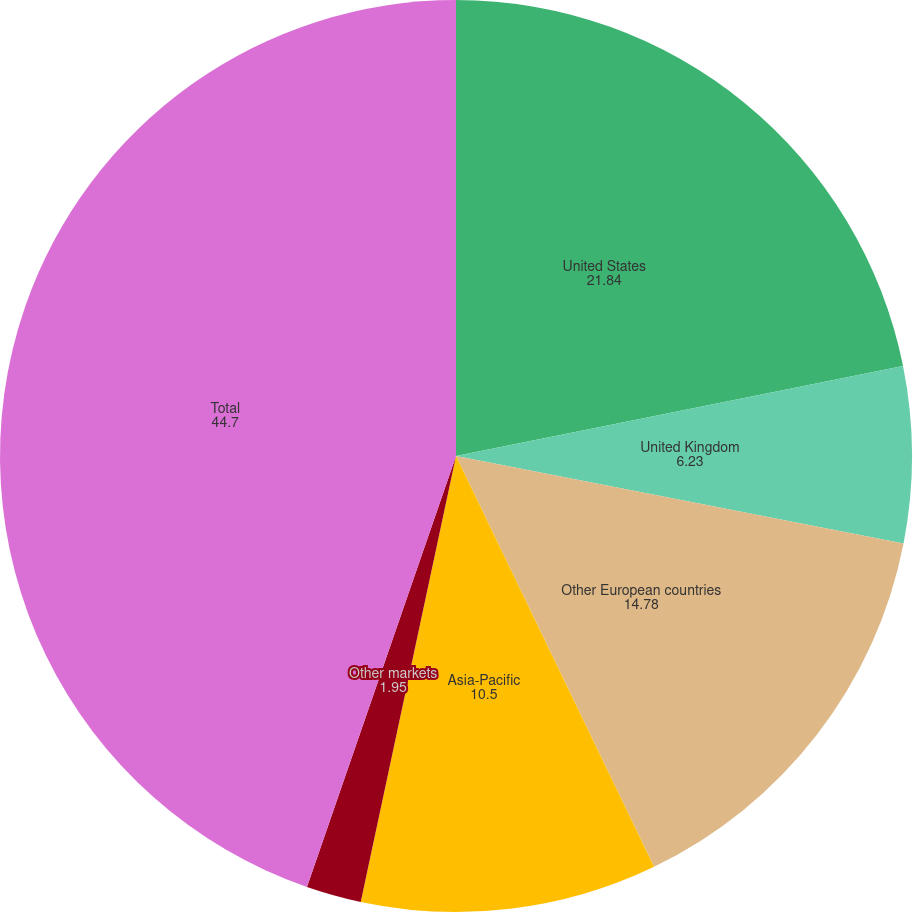Convert chart. <chart><loc_0><loc_0><loc_500><loc_500><pie_chart><fcel>United States<fcel>United Kingdom<fcel>Other European countries<fcel>Asia-Pacific<fcel>Other markets<fcel>Total<nl><fcel>21.84%<fcel>6.23%<fcel>14.78%<fcel>10.5%<fcel>1.95%<fcel>44.7%<nl></chart> 